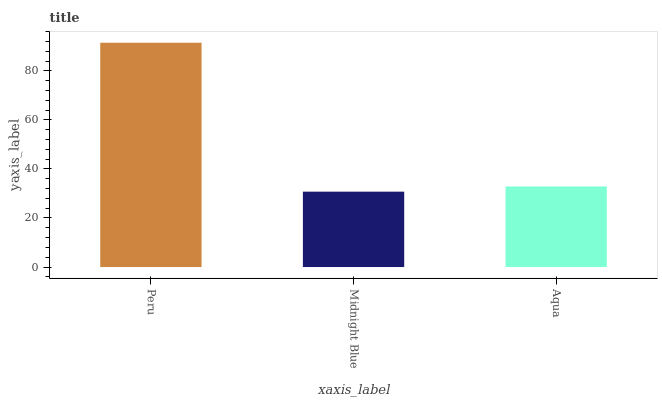Is Midnight Blue the minimum?
Answer yes or no. Yes. Is Peru the maximum?
Answer yes or no. Yes. Is Aqua the minimum?
Answer yes or no. No. Is Aqua the maximum?
Answer yes or no. No. Is Aqua greater than Midnight Blue?
Answer yes or no. Yes. Is Midnight Blue less than Aqua?
Answer yes or no. Yes. Is Midnight Blue greater than Aqua?
Answer yes or no. No. Is Aqua less than Midnight Blue?
Answer yes or no. No. Is Aqua the high median?
Answer yes or no. Yes. Is Aqua the low median?
Answer yes or no. Yes. Is Midnight Blue the high median?
Answer yes or no. No. Is Peru the low median?
Answer yes or no. No. 